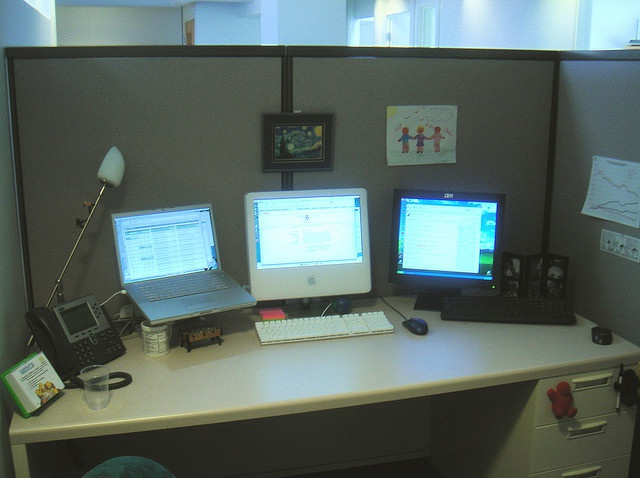Describe the objects in this image and their specific colors. I can see tv in gray, lightblue, and darkgray tones, laptop in gray, lightblue, and teal tones, tv in gray, cyan, lightblue, black, and blue tones, keyboard in black and gray tones, and keyboard in gray, lightblue, and darkgray tones in this image. 